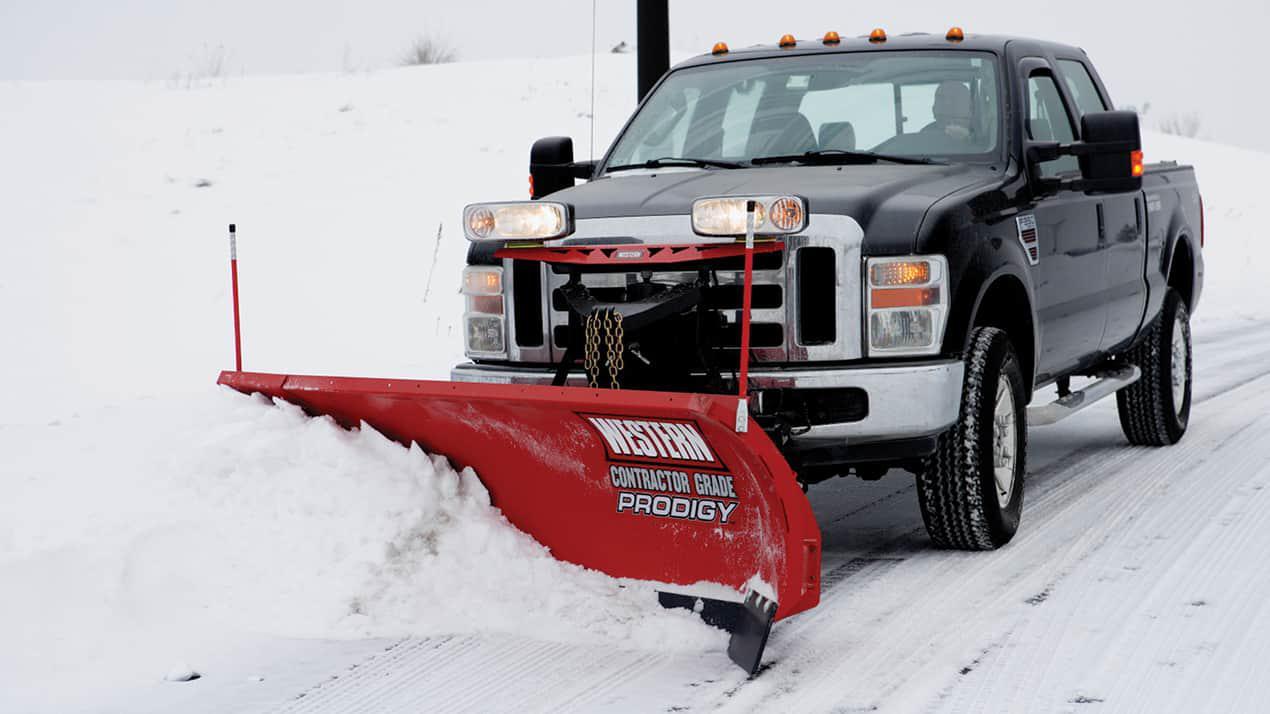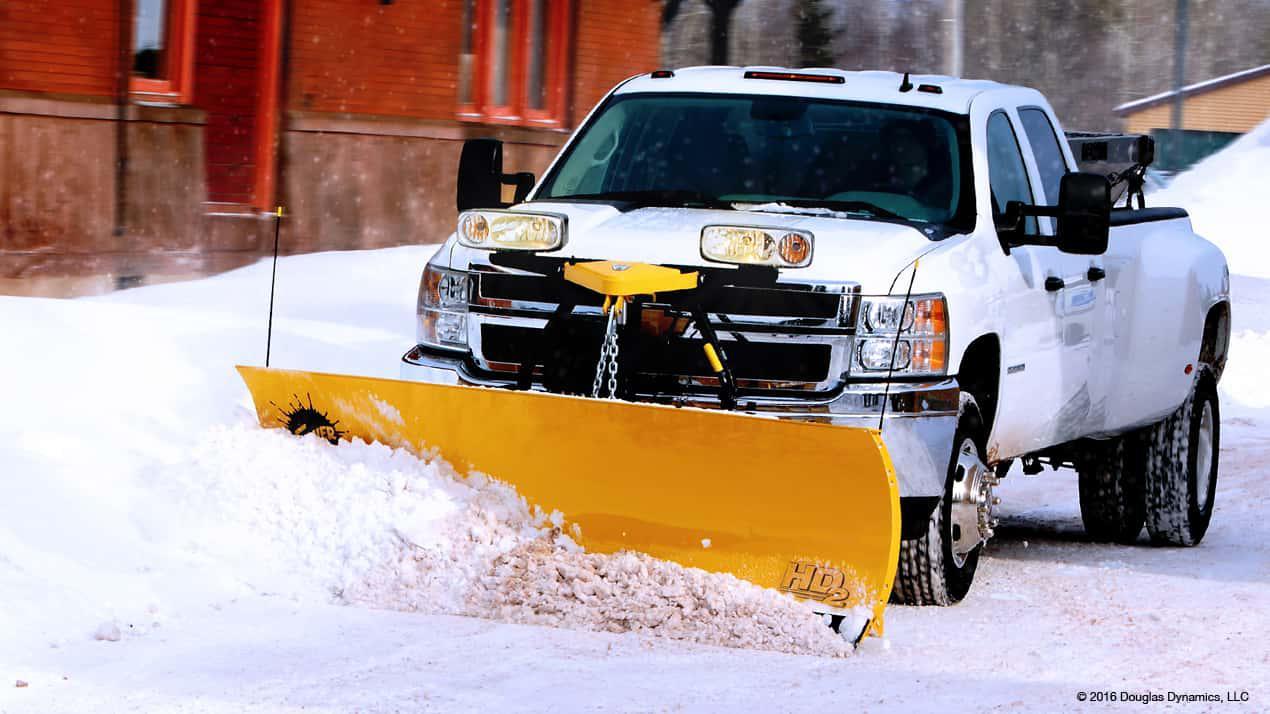The first image is the image on the left, the second image is the image on the right. Evaluate the accuracy of this statement regarding the images: "The scraper in the image on the left is red.". Is it true? Answer yes or no. Yes. 